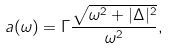<formula> <loc_0><loc_0><loc_500><loc_500>a ( \omega ) = \Gamma \frac { \sqrt { \omega ^ { 2 } + | \Delta | ^ { 2 } } } { \omega ^ { 2 } } ,</formula> 